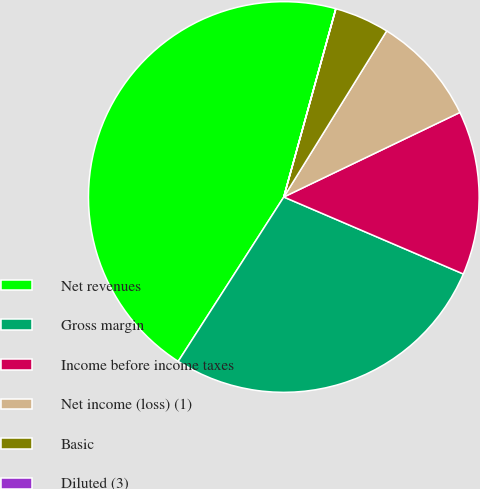Convert chart. <chart><loc_0><loc_0><loc_500><loc_500><pie_chart><fcel>Net revenues<fcel>Gross margin<fcel>Income before income taxes<fcel>Net income (loss) (1)<fcel>Basic<fcel>Diluted (3)<nl><fcel>45.2%<fcel>27.64%<fcel>13.57%<fcel>9.05%<fcel>4.53%<fcel>0.01%<nl></chart> 